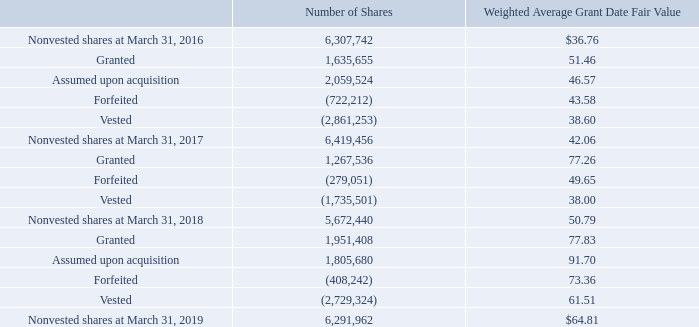Combined Incentive Plan Information
RSU share activity under the 2004 Plan is set forth below:
The total intrinsic value of RSUs which vested during the years ended March 31, 2019, 2018 and 2017 was $229.3 million, $146.0 million and $166.1 million, respectively. The aggregate intrinsic value of RSUs outstanding at March 31, 2019 was $522.0 million, calculated based on the closing price of the Company's common stock of $82.96 per share on March 29, 2019. At March 31, 2019, the weighted average remaining expense recognition period was 1.91 years.
What was the total intrinsic value of RSUs which vested during 2019?
Answer scale should be: million. 229.3. What was the number of granted shares in 2016? 1,635,655. What was the Weighted Average Grant Date Fair Value for nonvested shares at March 31, 2017? 42.06. What was the change in the weighted average grant date fair value of nonvested shares between 2016 and 2017? 42.06-36.76
Answer: 5.3. What was the change in the number of vested shares between 2017 and 2018? -2,729,324-(-1,735,501)
Answer: -993823. What was the percentage change in the number of nonvested shares between 2018 and 2019?
Answer scale should be: percent. (6,291,962-5,672,440)/5,672,440
Answer: 10.92. 